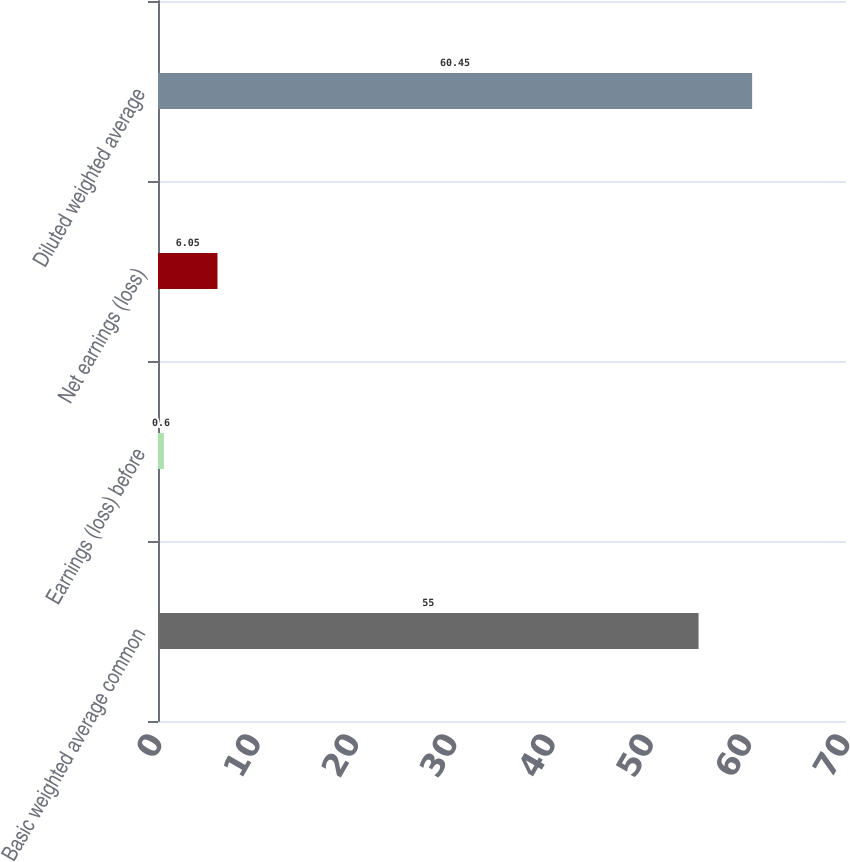Convert chart. <chart><loc_0><loc_0><loc_500><loc_500><bar_chart><fcel>Basic weighted average common<fcel>Earnings (loss) before<fcel>Net earnings (loss)<fcel>Diluted weighted average<nl><fcel>55<fcel>0.6<fcel>6.05<fcel>60.45<nl></chart> 